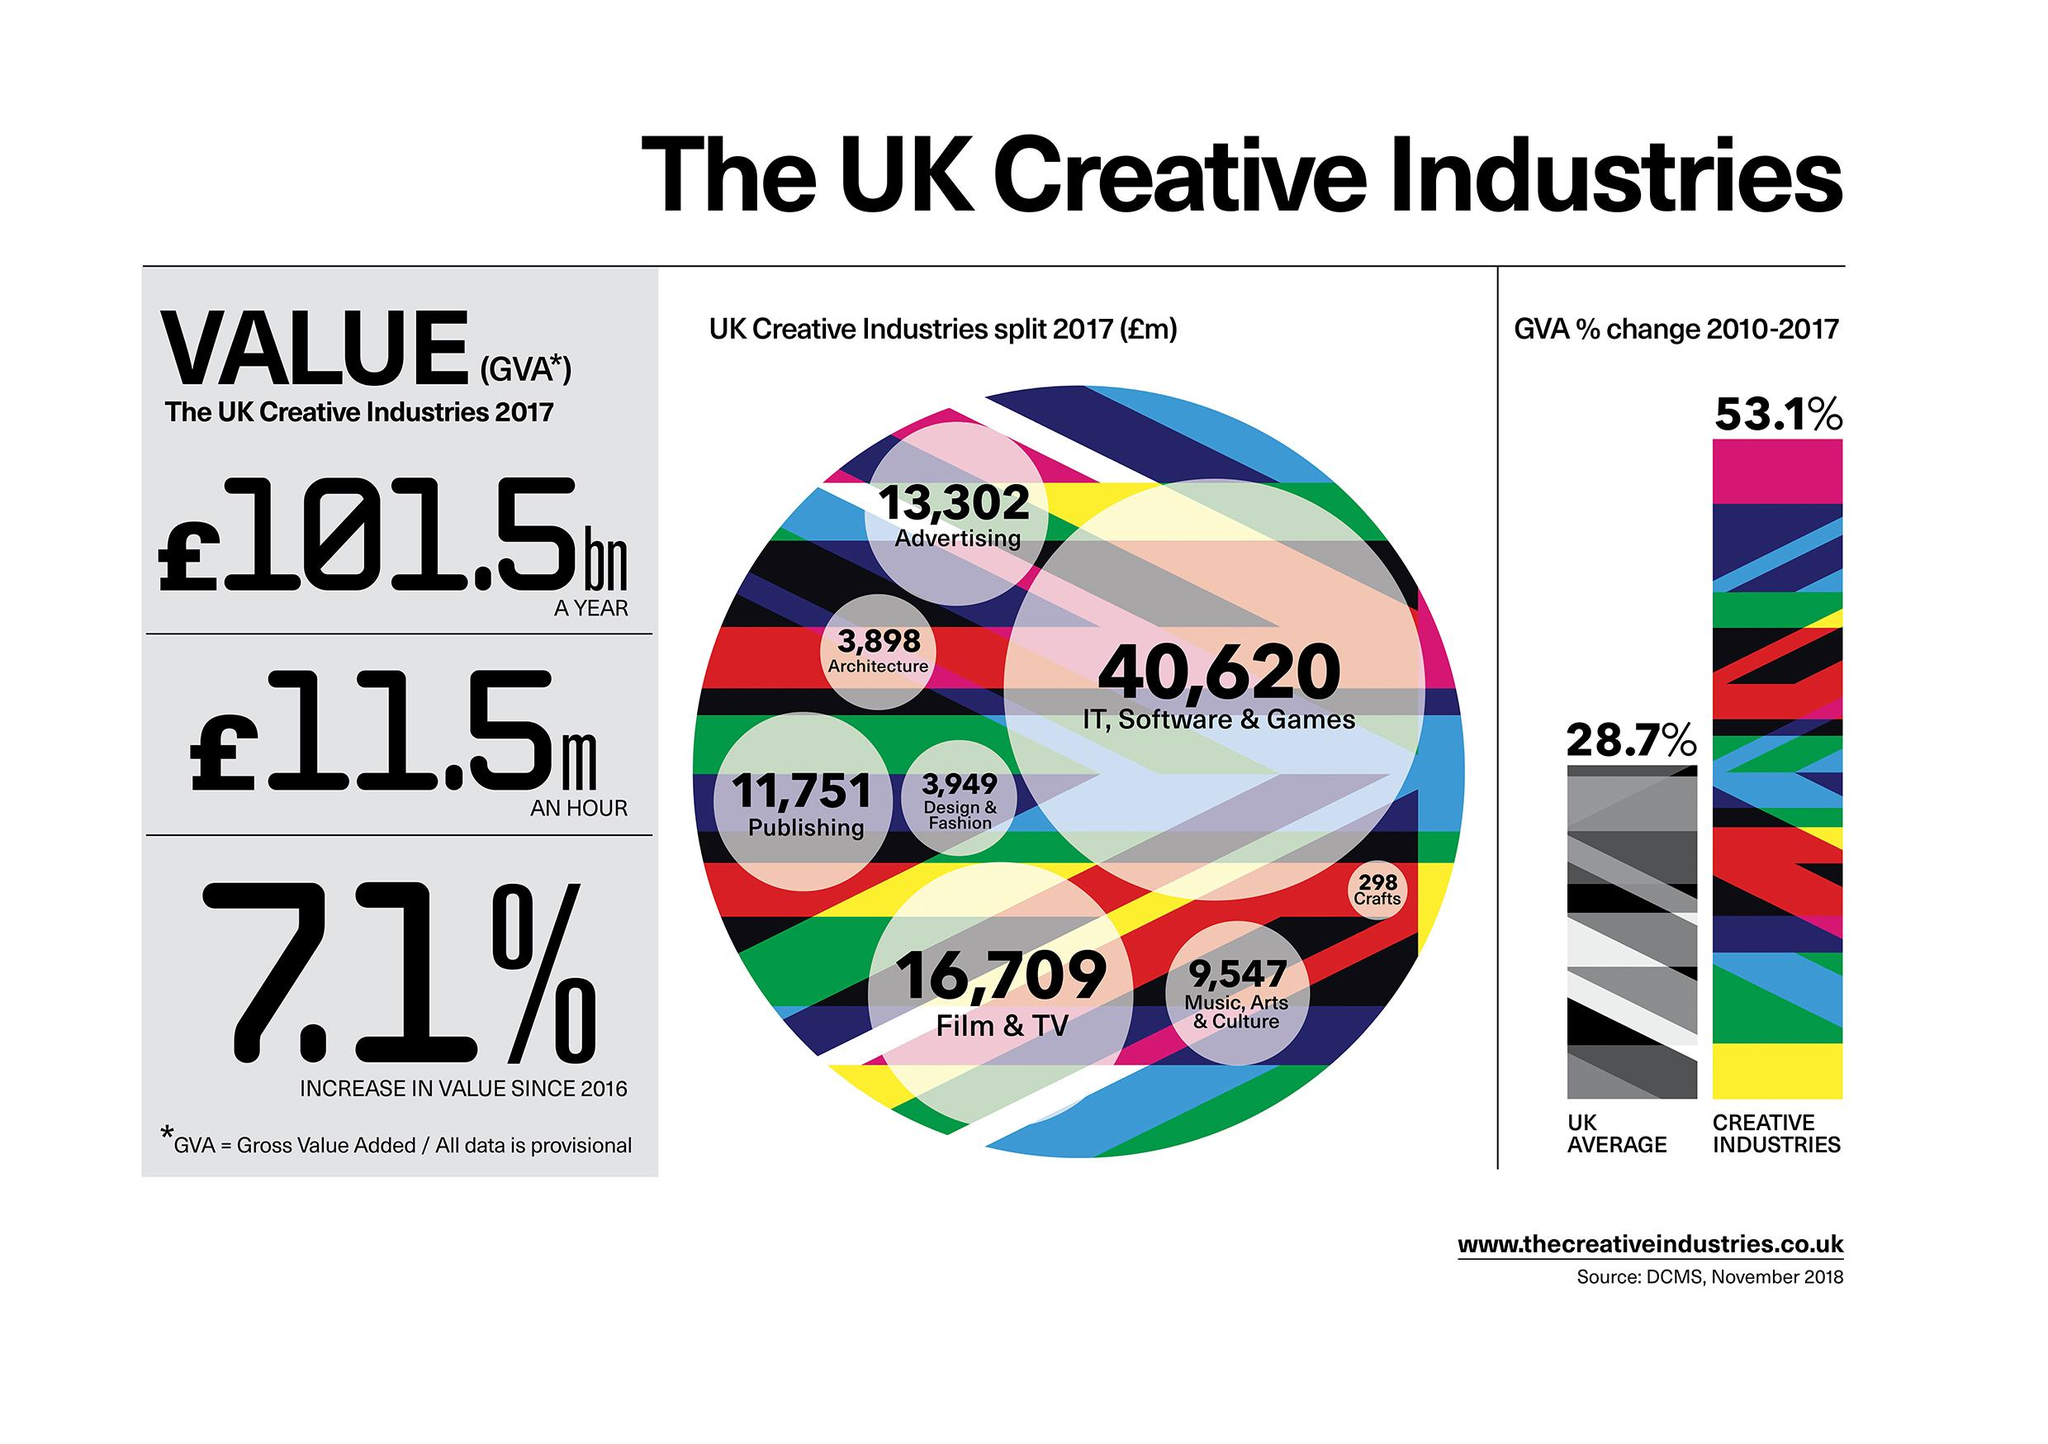Point out several critical features in this image. The creative industry with the largest share is IT, software, and games. The value of the UK creative industries in an hour is 11.5 million. The value of architecture, design, and fashion is 7847... The creative industry with the least share is crafts. The value of Publishing is significantly higher when compared to Music, Arts & Culture, as indicated by the score of 2204. 